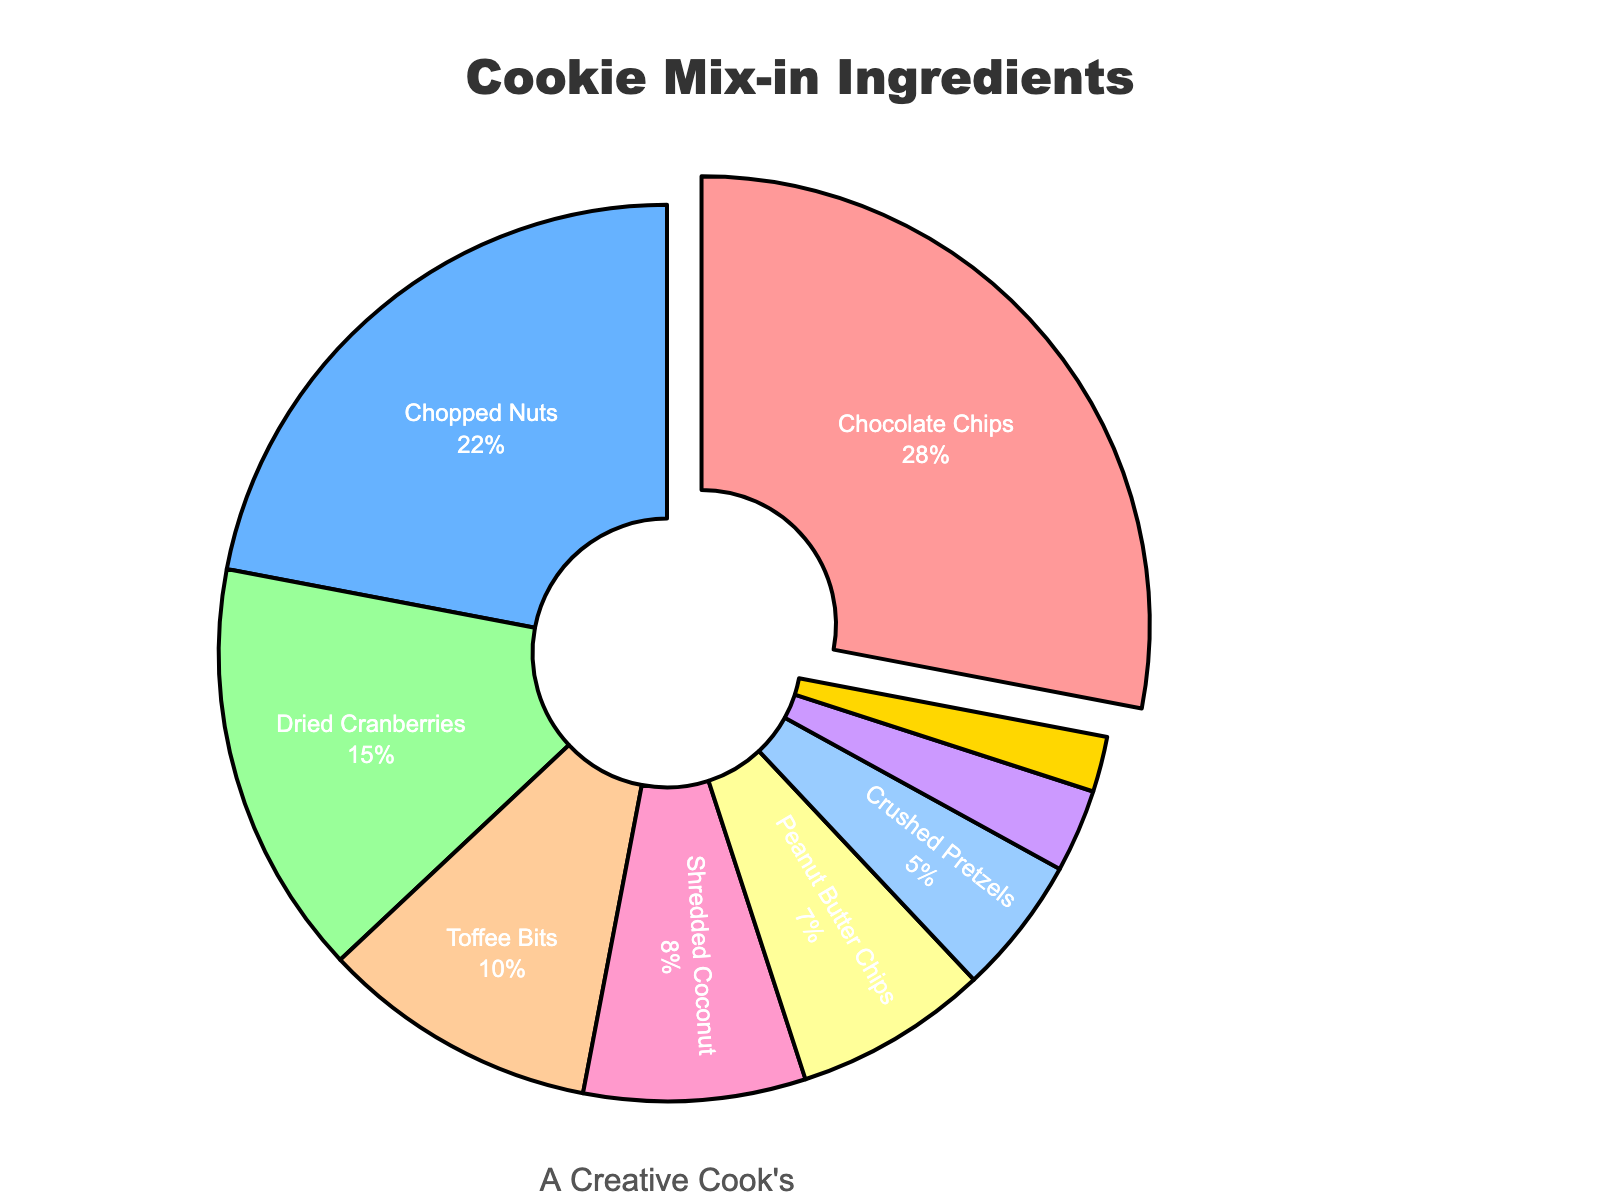What is the percentage of Chocolate Chips in the mix? The graph shows the percentage values of each mix-in ingredient, and for Chocolate Chips, it is specifically labeled. Locate the Chocolate Chips segment and read its percentage.
Answer: 28% Which mix-in ingredient has the smallest share and what is it? Check the segment with the smallest percentage in the pie chart. The smallest share segment will be the one with 2% next to Sea Salt Caramel Pieces.
Answer: Sea Salt Caramel Pieces, 2% How much greater is the percentage of Chocolate Chips compared to Peanut Butter Chips? The percentage of Chocolate Chips is 28%, and the percentage of Peanut Butter Chips is 7%. Subtract the percentage of Peanut Butter Chips from the percentage of Chocolate Chips. 28% - 7% = 21%
Answer: 21% What are the combined percentage shares of Dried Cranberries and Shredded Coconut? Dried Cranberries are 15%, and Shredded Coconut is 8%. Add these two values together. 15% + 8% = 23%
Answer: 23% Which mix-in ingredient is visually highlighted by being slightly separated from the rest of the pie chart? Examine the pie chart for sections that are pulled outward compared to the rest. The highlighted section is Chocolate Chips, which has the largest share and is slightly separated.
Answer: Chocolate Chips How do the percentages of Toffee Bits and Crushed Pretzels compare, and which one is higher? Toffee Bits have a percentage of 10%, while Crushed Pretzels have 5%. Compare the values to see which one is larger. Toffee Bits is higher at 10%.
Answer: Toffee Bits, 10% If the total percentage of mix-in ingredients must equal 100%, what’s the percentage share of the mix-in ingredients other than Chocolate Chips and Chopped Nuts? First, find the combined percentage of Chocolate Chips and Chopped Nuts, which is 28% + 22% = 50%. To find the other ingredients’ share, subtract this from 100%. 100% – 50% = 50%.
Answer: 50% What is the median percentage value of all the mix-in ingredients? List all the percentages in ascending order: 2%, 3%, 5%, 7%, 8%, 10%, 15%, 22%, 28%. The median value is the one in the middle position of this ordered list. The middle position (5th value) is 8% (Shredded Coconut).
Answer: 8% What is the difference between the highest and lowest mix-in percentages? The highest percentage is Chocolate Chips at 28%, and the lowest is Sea Salt Caramel Pieces at 2%. Subtract the lowest percentage from the highest: 28% - 2% = 26%.
Answer: 26% Which color corresponds to the Chopped Nuts segment in the pie chart? Identify the Chopped Nuts segment and correlate it to its associated color. Chopped Nuts appears in the second segment, which is colored blue.
Answer: blue 